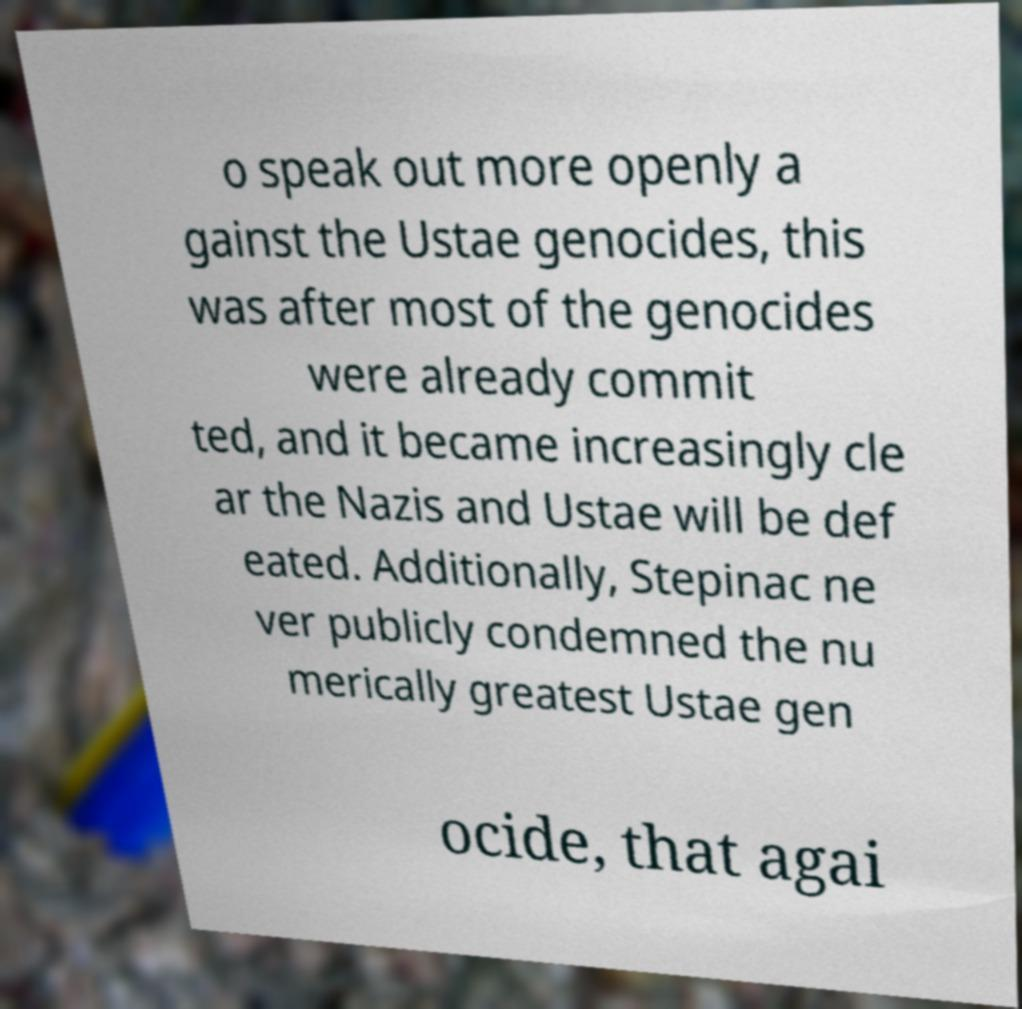Can you read and provide the text displayed in the image?This photo seems to have some interesting text. Can you extract and type it out for me? o speak out more openly a gainst the Ustae genocides, this was after most of the genocides were already commit ted, and it became increasingly cle ar the Nazis and Ustae will be def eated. Additionally, Stepinac ne ver publicly condemned the nu merically greatest Ustae gen ocide, that agai 